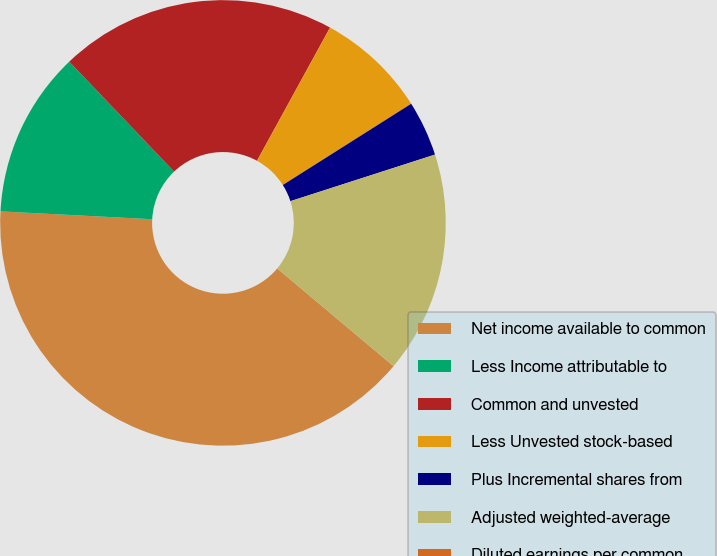Convert chart. <chart><loc_0><loc_0><loc_500><loc_500><pie_chart><fcel>Net income available to common<fcel>Less Income attributable to<fcel>Common and unvested<fcel>Less Unvested stock-based<fcel>Plus Incremental shares from<fcel>Adjusted weighted-average<fcel>Diluted earnings per common<nl><fcel>39.71%<fcel>12.06%<fcel>20.1%<fcel>8.04%<fcel>4.02%<fcel>16.08%<fcel>0.0%<nl></chart> 